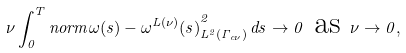<formula> <loc_0><loc_0><loc_500><loc_500>\nu \int _ { 0 } ^ { T } n o r m { \omega ( s ) - \omega ^ { L ( \nu ) } ( s ) } _ { L ^ { 2 } ( \Gamma _ { c \nu } ) } ^ { 2 } \, d s \to 0 \text { as } \nu \to 0 ,</formula> 